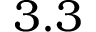Convert formula to latex. <formula><loc_0><loc_0><loc_500><loc_500>3 . 3</formula> 